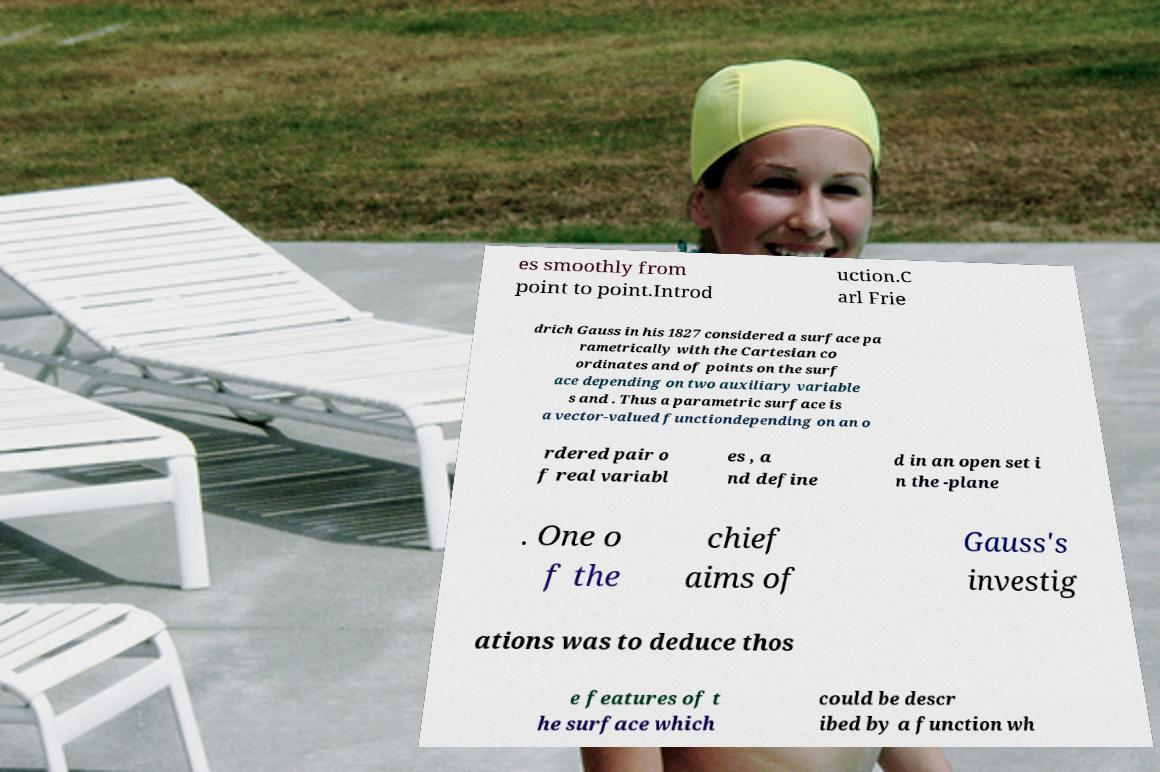Can you read and provide the text displayed in the image?This photo seems to have some interesting text. Can you extract and type it out for me? es smoothly from point to point.Introd uction.C arl Frie drich Gauss in his 1827 considered a surface pa rametrically with the Cartesian co ordinates and of points on the surf ace depending on two auxiliary variable s and . Thus a parametric surface is a vector-valued functiondepending on an o rdered pair o f real variabl es , a nd define d in an open set i n the -plane . One o f the chief aims of Gauss's investig ations was to deduce thos e features of t he surface which could be descr ibed by a function wh 